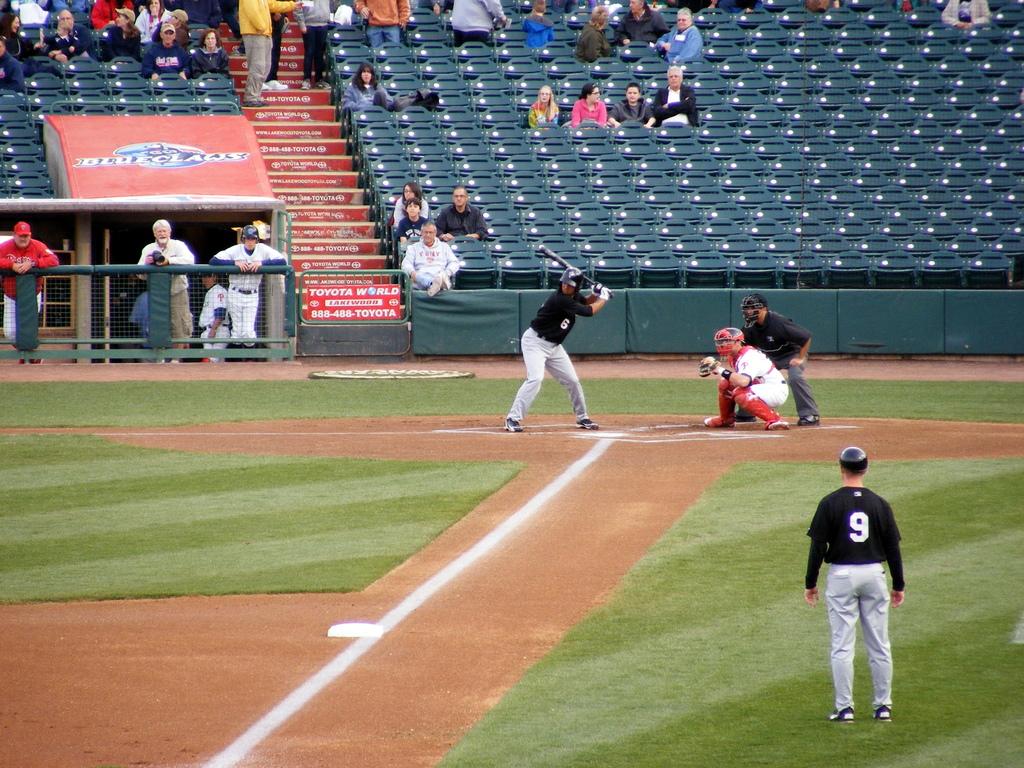What number is that baseball player?
Offer a very short reply. 9. What is the sponsor on the red stairs?
Keep it short and to the point. Toyota. 